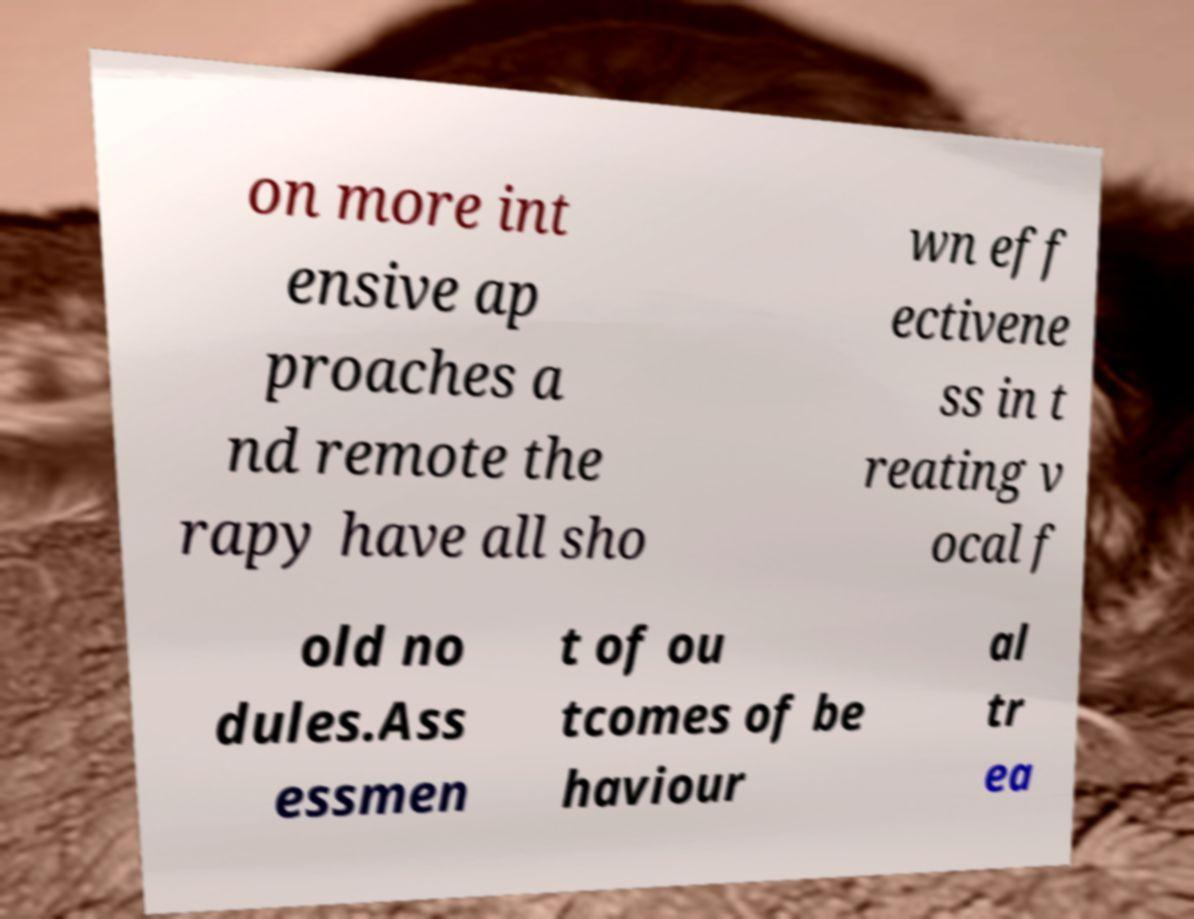For documentation purposes, I need the text within this image transcribed. Could you provide that? on more int ensive ap proaches a nd remote the rapy have all sho wn eff ectivene ss in t reating v ocal f old no dules.Ass essmen t of ou tcomes of be haviour al tr ea 